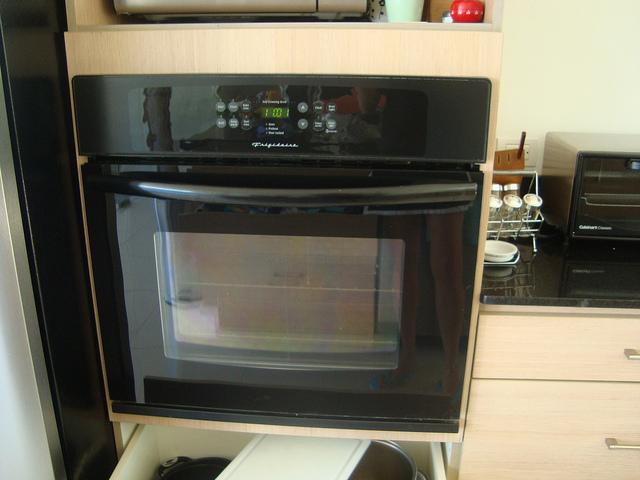What is sitting next to toaster oven?
Short answer required. Spice rack. Is this the kitchen area?
Be succinct. Yes. Can you see inside the oven?
Keep it brief. Yes. Is there a lot of food inside of the microwave?
Keep it brief. No. 